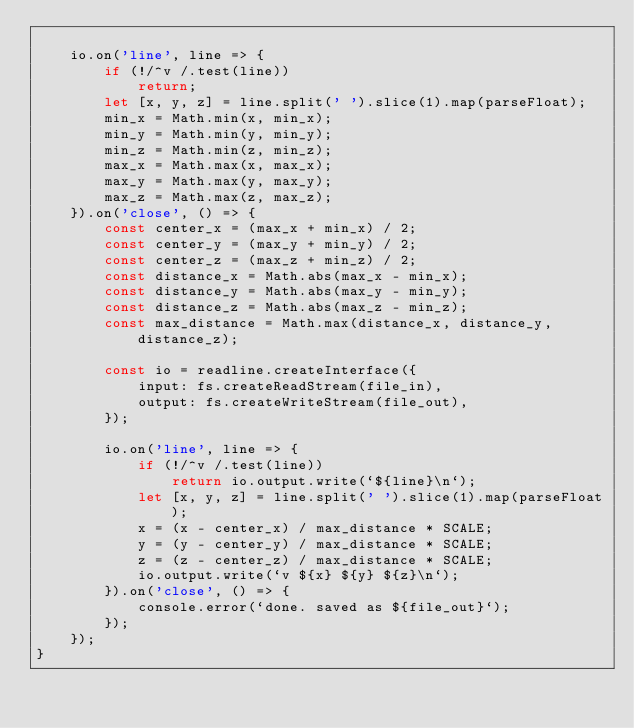Convert code to text. <code><loc_0><loc_0><loc_500><loc_500><_JavaScript_>
	io.on('line', line => {
		if (!/^v /.test(line))
			return;
		let [x, y, z] = line.split(' ').slice(1).map(parseFloat);
		min_x = Math.min(x, min_x);
		min_y = Math.min(y, min_y);
		min_z = Math.min(z, min_z);
		max_x = Math.max(x, max_x);
		max_y = Math.max(y, max_y);
		max_z = Math.max(z, max_z);
	}).on('close', () => {
		const center_x = (max_x + min_x) / 2;
		const center_y = (max_y + min_y) / 2;
		const center_z = (max_z + min_z) / 2;
		const distance_x = Math.abs(max_x - min_x);
		const distance_y = Math.abs(max_y - min_y);
		const distance_z = Math.abs(max_z - min_z);
		const max_distance = Math.max(distance_x, distance_y, distance_z);

		const io = readline.createInterface({
			input: fs.createReadStream(file_in),
			output: fs.createWriteStream(file_out),
		});

		io.on('line', line => {
			if (!/^v /.test(line))
				return io.output.write(`${line}\n`);
			let [x, y, z] = line.split(' ').slice(1).map(parseFloat);
			x = (x - center_x) / max_distance * SCALE;
			y = (y - center_y) / max_distance * SCALE;
			z = (z - center_z) / max_distance * SCALE;
			io.output.write(`v ${x} ${y} ${z}\n`);
		}).on('close', () => {
			console.error(`done. saved as ${file_out}`);
		});
	});
}</code> 